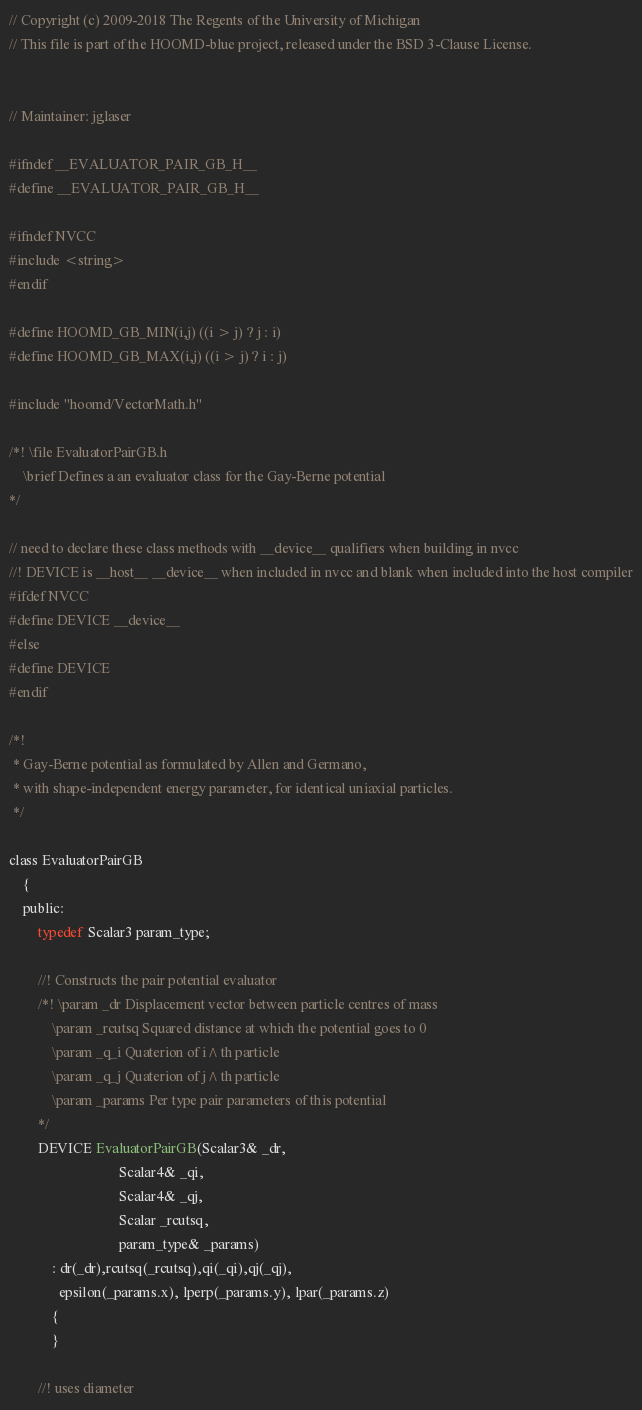<code> <loc_0><loc_0><loc_500><loc_500><_C_>// Copyright (c) 2009-2018 The Regents of the University of Michigan
// This file is part of the HOOMD-blue project, released under the BSD 3-Clause License.


// Maintainer: jglaser

#ifndef __EVALUATOR_PAIR_GB_H__
#define __EVALUATOR_PAIR_GB_H__

#ifndef NVCC
#include <string>
#endif

#define HOOMD_GB_MIN(i,j) ((i > j) ? j : i)
#define HOOMD_GB_MAX(i,j) ((i > j) ? i : j)

#include "hoomd/VectorMath.h"

/*! \file EvaluatorPairGB.h
    \brief Defines a an evaluator class for the Gay-Berne potential
*/

// need to declare these class methods with __device__ qualifiers when building in nvcc
//! DEVICE is __host__ __device__ when included in nvcc and blank when included into the host compiler
#ifdef NVCC
#define DEVICE __device__
#else
#define DEVICE
#endif

/*!
 * Gay-Berne potential as formulated by Allen and Germano,
 * with shape-independent energy parameter, for identical uniaxial particles.
 */

class EvaluatorPairGB
    {
    public:
        typedef Scalar3 param_type;

        //! Constructs the pair potential evaluator
        /*! \param _dr Displacement vector between particle centres of mass
            \param _rcutsq Squared distance at which the potential goes to 0
            \param _q_i Quaterion of i^th particle
            \param _q_j Quaterion of j^th particle
            \param _params Per type pair parameters of this potential
        */
        DEVICE EvaluatorPairGB(Scalar3& _dr,
                               Scalar4& _qi,
                               Scalar4& _qj,
                               Scalar _rcutsq,
                               param_type& _params)
            : dr(_dr),rcutsq(_rcutsq),qi(_qi),qj(_qj),
              epsilon(_params.x), lperp(_params.y), lpar(_params.z)
            {
            }

        //! uses diameter</code> 